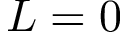Convert formula to latex. <formula><loc_0><loc_0><loc_500><loc_500>L = 0</formula> 